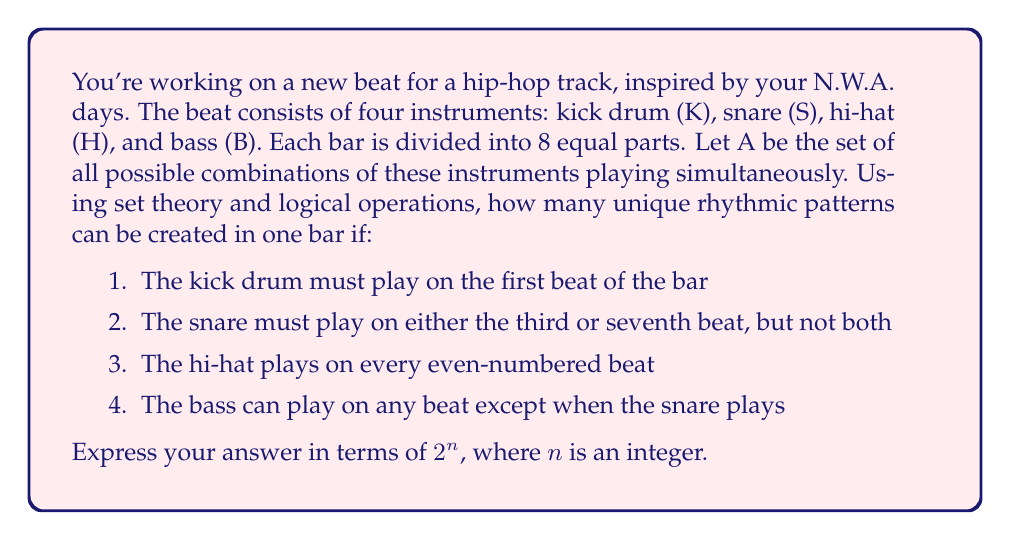Teach me how to tackle this problem. Let's approach this step-by-step using set theory and logical operations:

1) First, let's define our universal set A:
   $A = \{K, S, H, B\}$

2) Now, let's analyze each condition:

   a) Kick drum (K) must play on the first beat:
      This is fixed, so it doesn't contribute to the number of possibilities.

   b) Snare (S) must play on either the third or seventh beat, but not both:
      This gives us 2 possibilities.

   c) Hi-hat (H) plays on every even-numbered beat:
      This is fixed, so it doesn't contribute to the number of possibilities.

   d) Bass (B) can play on any beat except when the snare plays:
      We need to consider this for the remaining beats (2, 4, 5, 6, 8).

3) Let's count the possibilities:
   - Beat 1: K and H are fixed, B can play or not: 2 possibilities
   - Beat 2: H is fixed, B can play or not: 2 possibilities
   - Beat 3: S plays here or not (tied to beat 7), B plays if S doesn't: 2 possibilities
   - Beat 4: H is fixed, B can play or not: 2 possibilities
   - Beat 5: B can play or not: 2 possibilities
   - Beat 6: H is fixed, B can play or not: 2 possibilities
   - Beat 7: S plays here if it didn't on beat 3, B plays if S doesn't: (tied to beat 3)
   - Beat 8: H is fixed, B can play or not: 2 possibilities

4) Using the multiplication principle, the total number of possibilities is:
   $2 \times 2 \times 2 \times 2 \times 2 \times 2 = 2^6 = 64$

Therefore, there are 64 unique rhythmic patterns that can be created under these conditions.
Answer: $2^6$ 